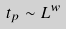<formula> <loc_0><loc_0><loc_500><loc_500>t _ { p } \sim L ^ { w }</formula> 